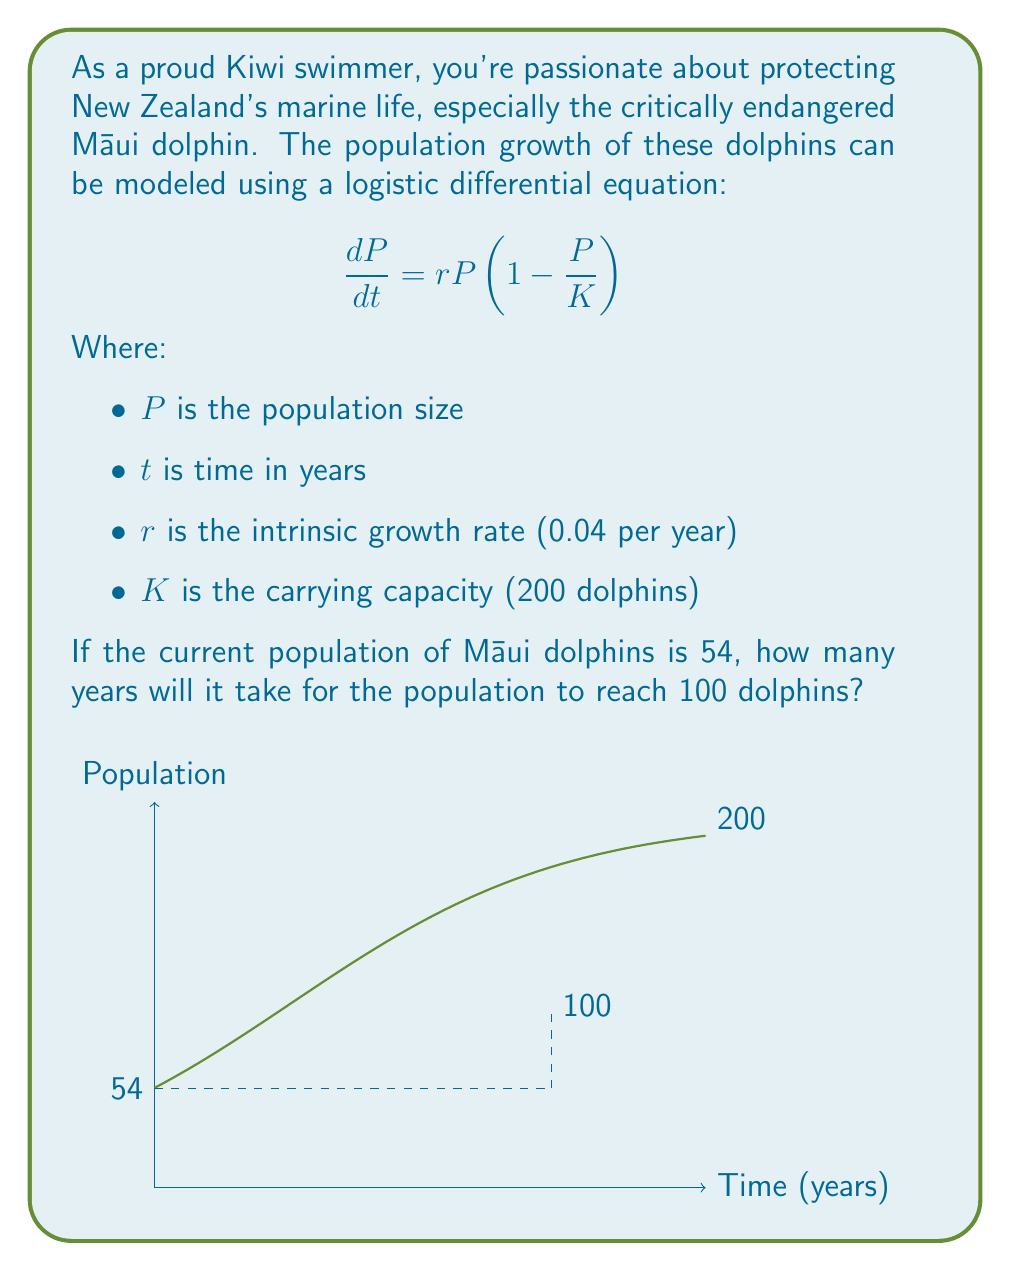Solve this math problem. Let's solve this step-by-step:

1) The logistic differential equation solution is:

   $$P(t) = \frac{K}{1 + (\frac{K}{P_0} - 1)e^{-rt}}$$

   Where $P_0$ is the initial population.

2) Substituting the given values:

   $$P(t) = \frac{200}{1 + (\frac{200}{54} - 1)e^{-0.04t}}$$

3) We want to find $t$ when $P(t) = 100$. Let's set up the equation:

   $$100 = \frac{200}{1 + (\frac{200}{54} - 1)e^{-0.04t}}$$

4) Simplify:

   $$100 = \frac{200}{1 + 2.7037e^{-0.04t}}$$

5) Multiply both sides by the denominator:

   $$100(1 + 2.7037e^{-0.04t}) = 200$$

6) Expand:

   $$100 + 270.37e^{-0.04t} = 200$$

7) Subtract 100 from both sides:

   $$270.37e^{-0.04t} = 100$$

8) Divide both sides by 270.37:

   $$e^{-0.04t} = 0.3699$$

9) Take the natural log of both sides:

   $$-0.04t = \ln(0.3699)$$

10) Solve for $t$:

    $$t = -\frac{\ln(0.3699)}{0.04} \approx 24.8$$

Therefore, it will take approximately 24.8 years for the population to reach 100 dolphins.
Answer: 24.8 years 